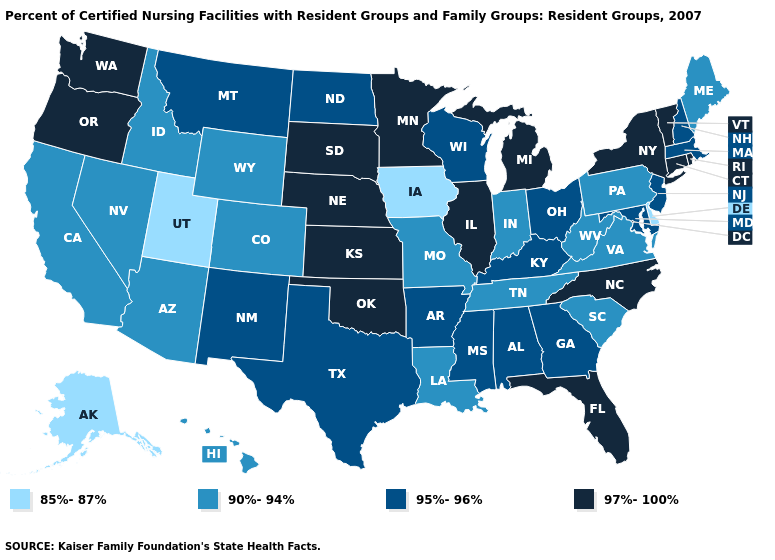Does Wisconsin have the same value as Arkansas?
Be succinct. Yes. Does Minnesota have the same value as Pennsylvania?
Short answer required. No. Does Oregon have the highest value in the USA?
Give a very brief answer. Yes. What is the value of Massachusetts?
Be succinct. 95%-96%. Name the states that have a value in the range 85%-87%?
Write a very short answer. Alaska, Delaware, Iowa, Utah. Which states hav the highest value in the Northeast?
Write a very short answer. Connecticut, New York, Rhode Island, Vermont. What is the value of Idaho?
Quick response, please. 90%-94%. Does Wisconsin have a lower value than Connecticut?
Be succinct. Yes. What is the value of West Virginia?
Keep it brief. 90%-94%. What is the value of Wisconsin?
Answer briefly. 95%-96%. What is the value of Wisconsin?
Be succinct. 95%-96%. What is the highest value in states that border New York?
Short answer required. 97%-100%. Among the states that border Utah , does Wyoming have the lowest value?
Answer briefly. Yes. What is the value of Wyoming?
Concise answer only. 90%-94%. 